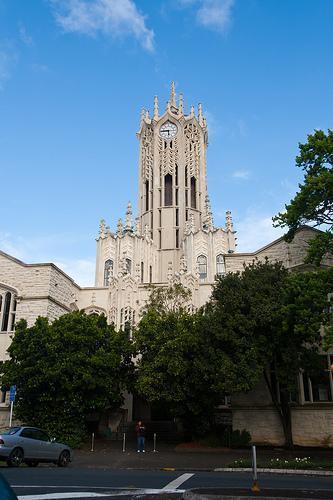How many people are in the picture?
Give a very brief answer. 1. 